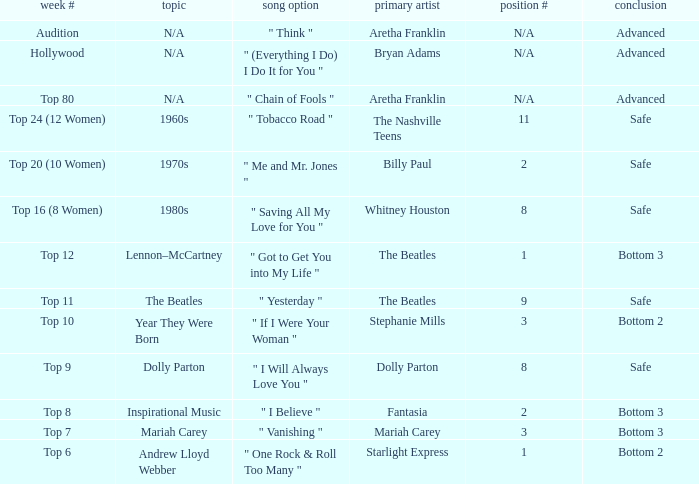Name the week number for andrew lloyd webber Top 6. 